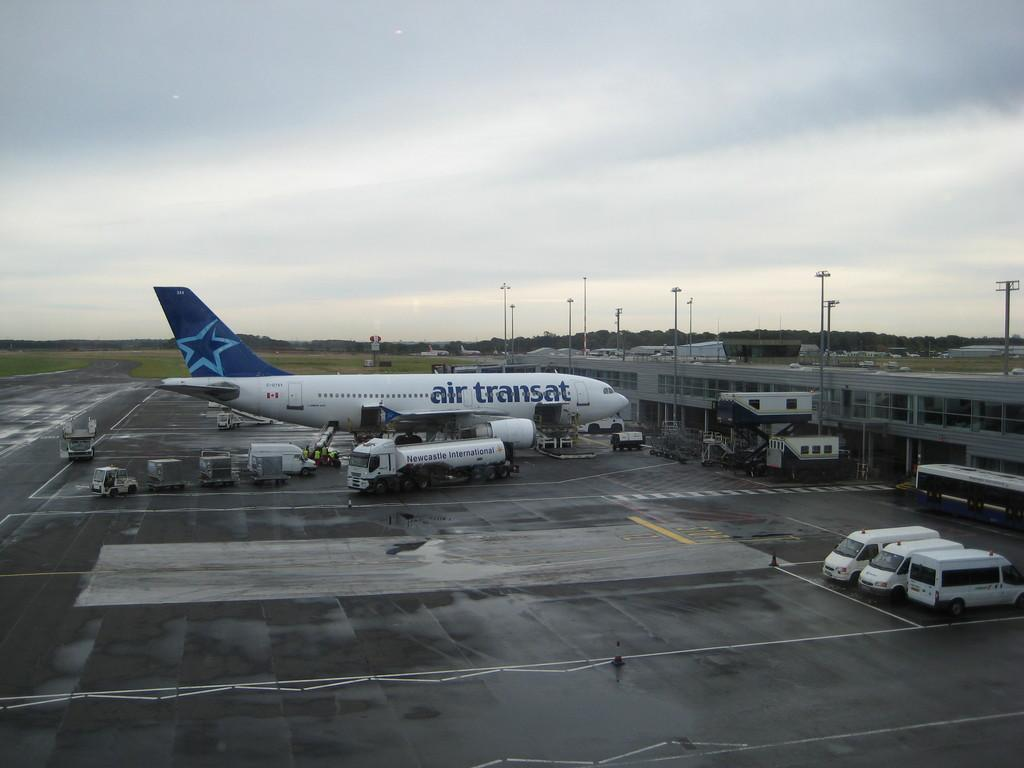<image>
Write a terse but informative summary of the picture. An Air Transat passenger plane parked at a gate. 